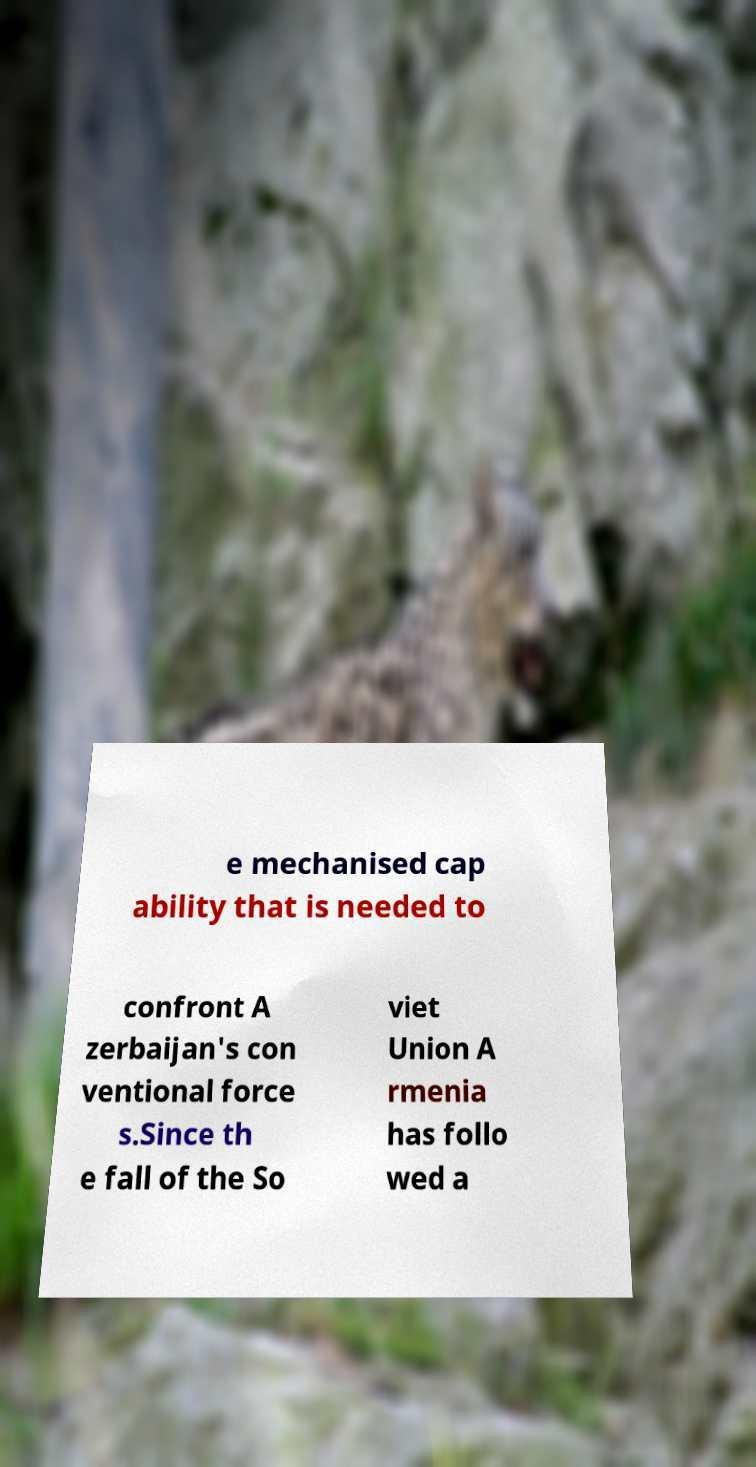Please identify and transcribe the text found in this image. e mechanised cap ability that is needed to confront A zerbaijan's con ventional force s.Since th e fall of the So viet Union A rmenia has follo wed a 